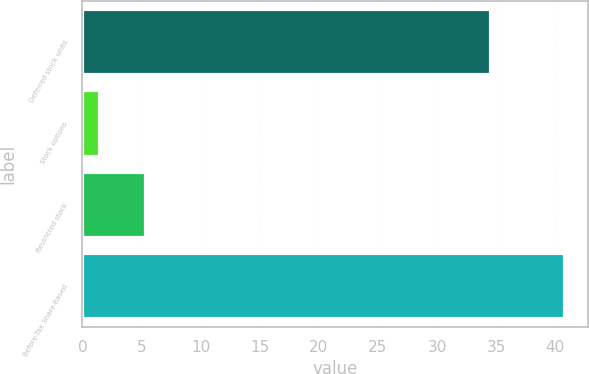<chart> <loc_0><loc_0><loc_500><loc_500><bar_chart><fcel>Deferred stock units<fcel>Stock options<fcel>Restricted stock<fcel>Before-Tax Share-Based<nl><fcel>34.5<fcel>1.4<fcel>5.33<fcel>40.7<nl></chart> 